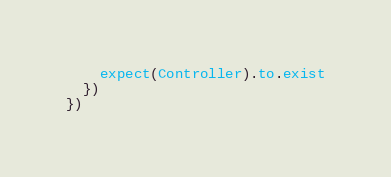Convert code to text. <code><loc_0><loc_0><loc_500><loc_500><_JavaScript_>    expect(Controller).to.exist
  })
})</code> 